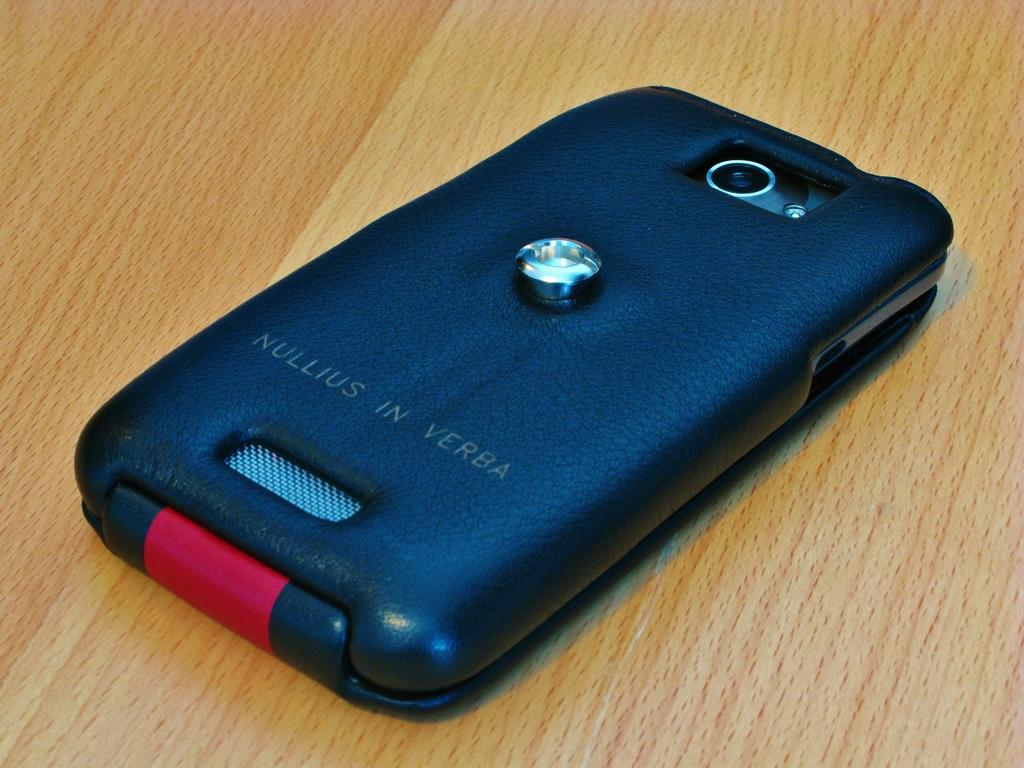<image>
Write a terse but informative summary of the picture. a flip phone with a black case on it that says 'nullius in verba' 